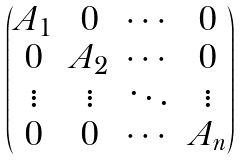Convert formula to latex. <formula><loc_0><loc_0><loc_500><loc_500>\begin{pmatrix} A _ { 1 } & 0 & \cdots & 0 \\ 0 & A _ { 2 } & \cdots & 0 \\ \vdots & \vdots & \ddots & \vdots \\ 0 & 0 & \cdots & A _ { n } \end{pmatrix}</formula> 